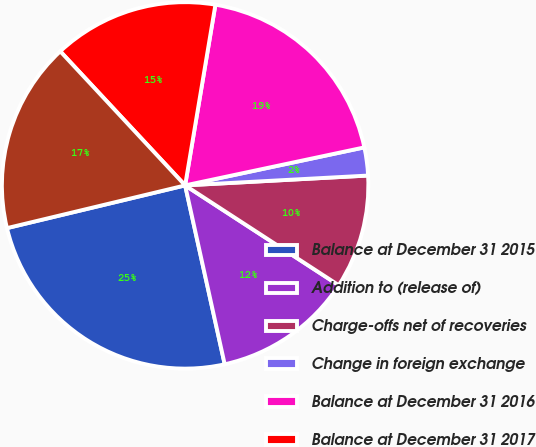Convert chart. <chart><loc_0><loc_0><loc_500><loc_500><pie_chart><fcel>Balance at December 31 2015<fcel>Addition to (release of)<fcel>Charge-offs net of recoveries<fcel>Change in foreign exchange<fcel>Balance at December 31 2016<fcel>Balance at December 31 2017<fcel>Balance at December 31 2018<nl><fcel>24.72%<fcel>12.36%<fcel>10.03%<fcel>2.47%<fcel>19.03%<fcel>14.58%<fcel>16.81%<nl></chart> 